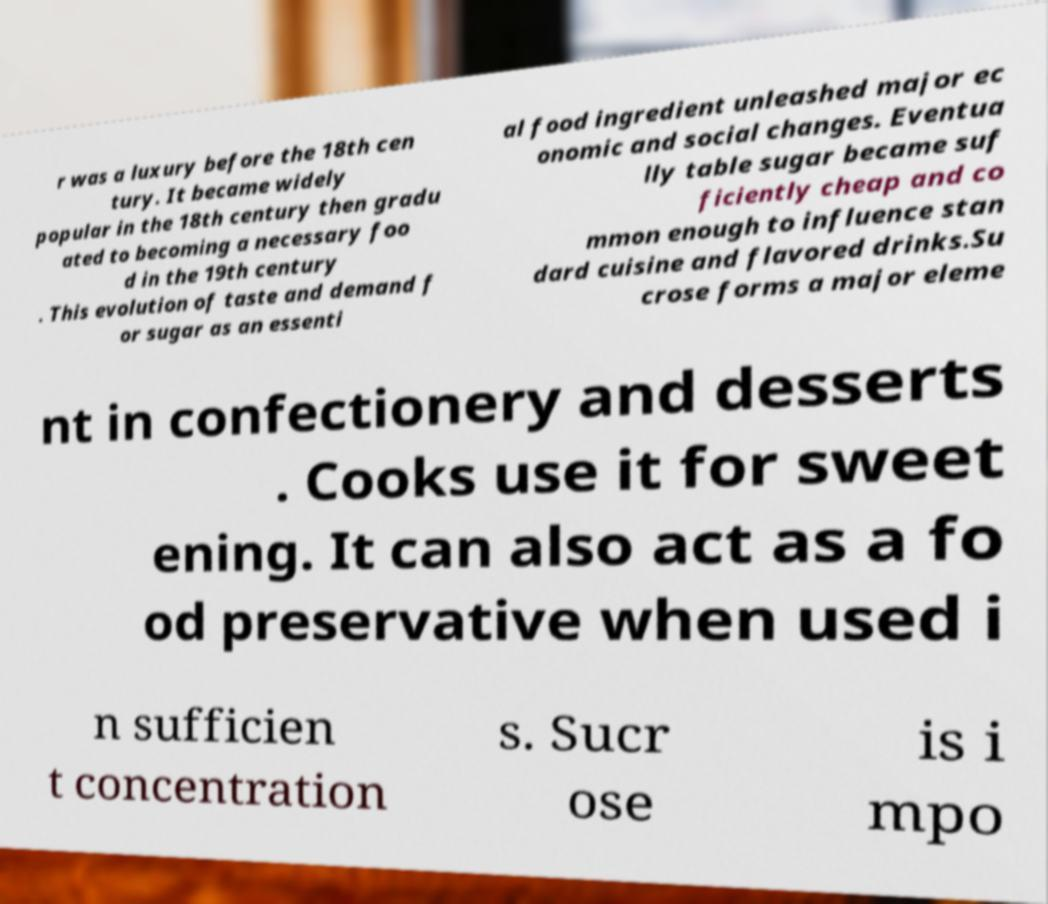What messages or text are displayed in this image? I need them in a readable, typed format. r was a luxury before the 18th cen tury. It became widely popular in the 18th century then gradu ated to becoming a necessary foo d in the 19th century . This evolution of taste and demand f or sugar as an essenti al food ingredient unleashed major ec onomic and social changes. Eventua lly table sugar became suf ficiently cheap and co mmon enough to influence stan dard cuisine and flavored drinks.Su crose forms a major eleme nt in confectionery and desserts . Cooks use it for sweet ening. It can also act as a fo od preservative when used i n sufficien t concentration s. Sucr ose is i mpo 